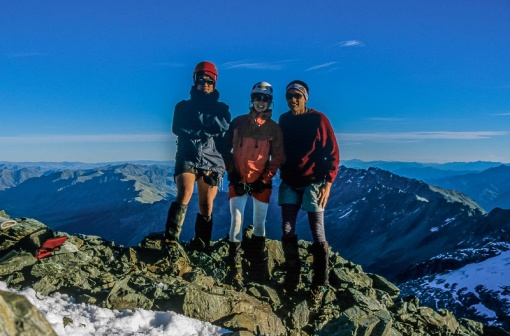If these adventurers were characters in a fantasy story, what roles would they play? In a fantasy story, these adventurers might take on distinctive roles that reflect their personalities and appearances. The person on the left, with their black jacket and red helmet, could be the group’s fearless leader, a skilled warrior known for their bravery and combat prowess. They might wield a mystical sword passed down through generations, symbolizing their unyielding spirit.

The middle adventurer, wearing a blue jacket and red pants along with a white helmet, might be the wise mage or healer of the group. Their knowledge of ancient spells and medicinal herbs could be crucial in guiding the team through magical landscapes and healing wounds inflicted by mythical creatures. They could also possess a mysterious artifact that enhances their powers, a memento from a forgotten era.

Lastly, the adventurer on the right, combining a red jacket with black pants and a matching helmet, could be the nimble rogue or scout. They’d be adept at stealth and reconnaissance, navigating through treacherous terrains and spotting dangers before they approach. With an unmatched agility and a set of finely tuned tools, they’d ensure the group's safe passage and uncover hidden secrets that others overlook.

Together, they’d embark on epic quests, overcoming fantastical challenges and seeking out legendary treasures, each member’s unique abilities complementing the others' in their shared journey. Imagine a day in their lives after returning from the climb. After the climb, a typical day in their lives might start with a morning of rest and recovery. They could gather around a hearty breakfast, sharing their favorite moments from the adventure and discussing plans for future climbs. The day could then involve some maintenance of their gear—repairing worn-out equipment and cleaning their tools to ensure they're ready for the next expedition.

In the afternoon, they might visit a local park or engage in light training exercises to keep their fitness levels up. This could be followed by a visit to a mountaineering club or a workshop, where they would exchange stories with fellow adventurers, gather new tips, and possibly even mentor aspiring climbers.

In the evening, the group might come together for a home-cooked meal, prepared using recipes inspired by the various cultures and regions they've visited. They'd enjoy the meal while reminiscing over past adventures and watching a documentary about famous mountain expeditions, garnering inspiration and ideas for their future challenges. The day would end with each member taking some quiet time to reflect, journal their experiences, and mentally prepare for the next great adventure that lies ahead. 